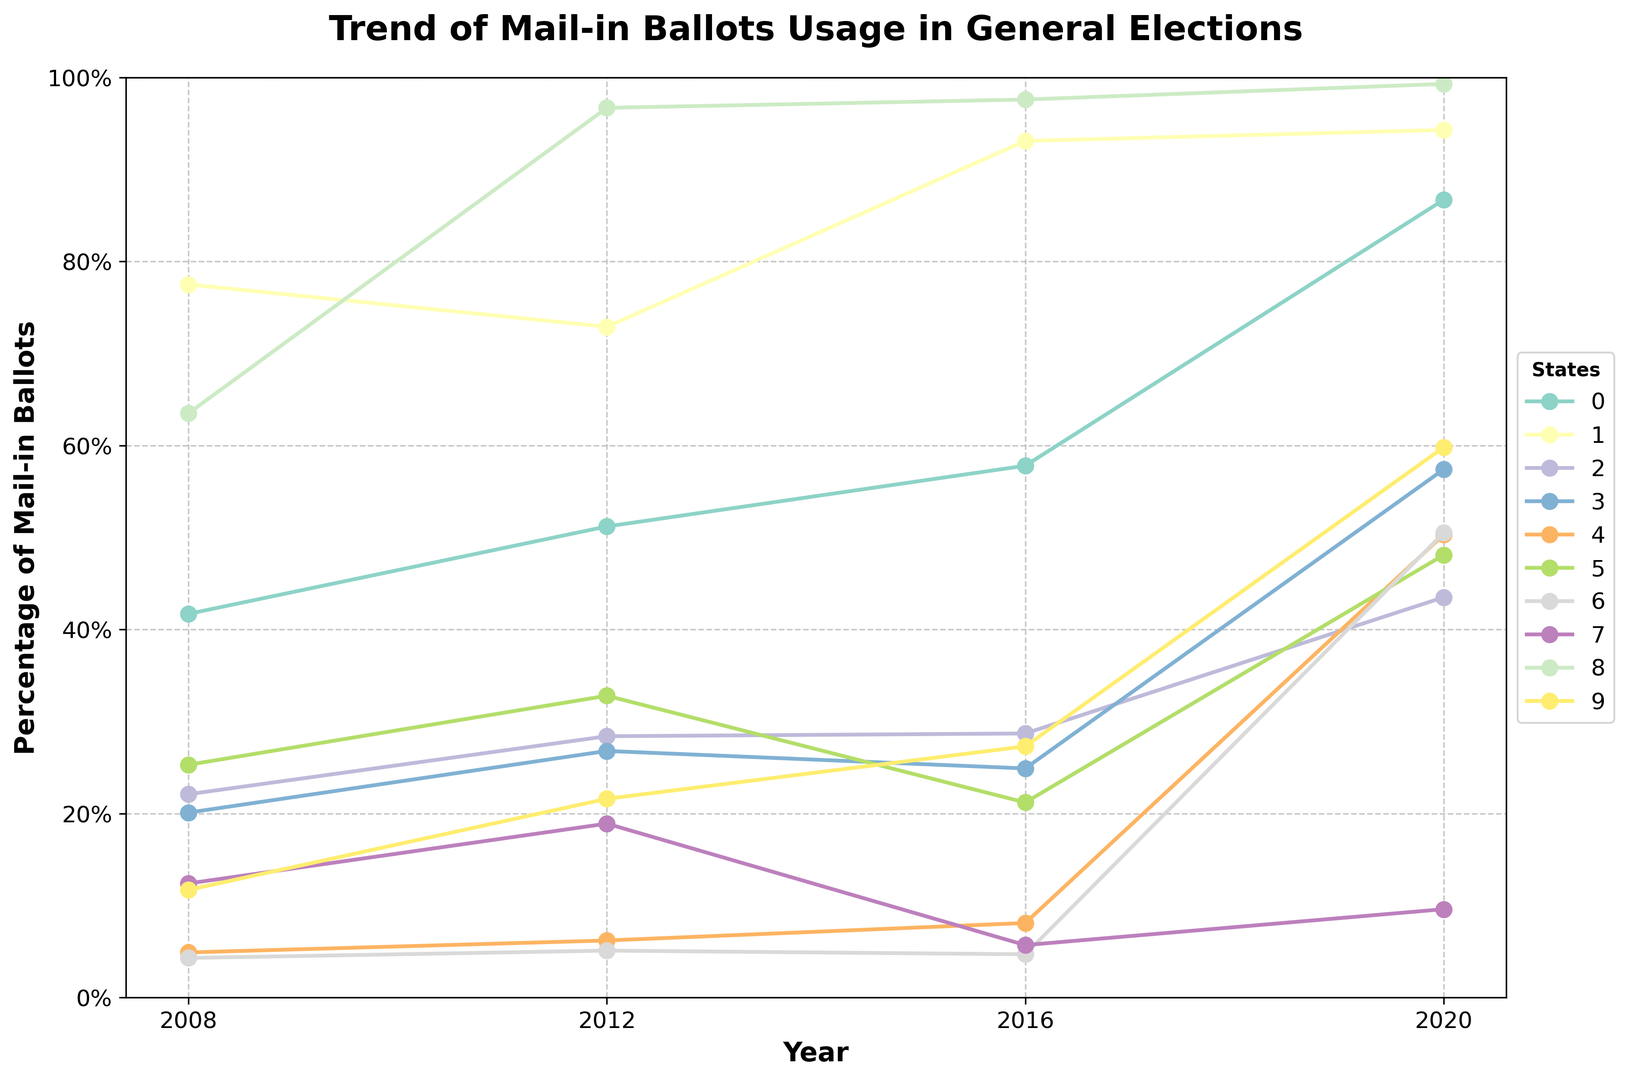Which state had the highest percentage of mail-in ballots in 2020? The highest point on the figure for 2020 is around 99.3%, which belongs to Washington.
Answer: Washington Which states saw an increase in the percentage of mail-in ballots used from 2016 to 2020? By comparing the 2016 and 2020 points on the graph, we can see that California, Florida, Michigan, New York, Ohio, Pennsylvania, and Wisconsin all saw an increase.
Answer: California, Florida, Michigan, New York, Ohio, Pennsylvania, Wisconsin Which state had a decrease in mail-in ballot usage between 2012 and 2016? By looking at the lines and comparing the 2012 and 2016 points, Texas is the only state where the percentage of mail-in ballots decreased.
Answer: Texas What was the average percentage of mail-in ballots in California over the four election years? Summing the percentages for California over the years (41.7 + 51.2 + 57.8 + 86.7) and then dividing by 4 gives the average: (41.7 + 51.2 + 57.8 + 86.7) / 4 = 59.35%.
Answer: 59.35% Which state had the largest increase in mail-in ballot percentage from 2008 to 2020? By calculating the difference in mail-in ballot percentages from 2008 to 2020 for each state, Pennsylvania had the largest increase: (50.5 - 4.3) = 46.2%.
Answer: Pennsylvania What trend do we observe for Florida from 2008 to 2020? Observing the graph, the line for Florida shows an upward trend in mail-in ballot usage each election year.
Answer: Upward trend In 2008, which state had the lowest percentage of mail-in ballots? By looking at the 2008 points on the graph, Pennsylvania had the lowest percentage with 4.3%.
Answer: Pennsylvania How did New York's mail-in ballot percentage change from 2012 to 2020? From 2012 to 2020, New York's mail-in ballot percentage increased from 6.2% to 50.3%, showing a significant rise.
Answer: Increased Which state had a nearly consistent high percentage of mail-in ballots throughout the years? Washington state consistently maintained a high percentage of mail-in ballots, starting from 63.5% in 2008 to 99.3% in 2020.
Answer: Washington What is the percentage difference in mail-in ballots for Ohio between 2008 and 2020? Subtracting Ohio's 2008 percentage from its 2020 percentage: 48.1% - 25.3% provides the difference: 48.1% - 25.3% = 22.8%.
Answer: 22.8% 